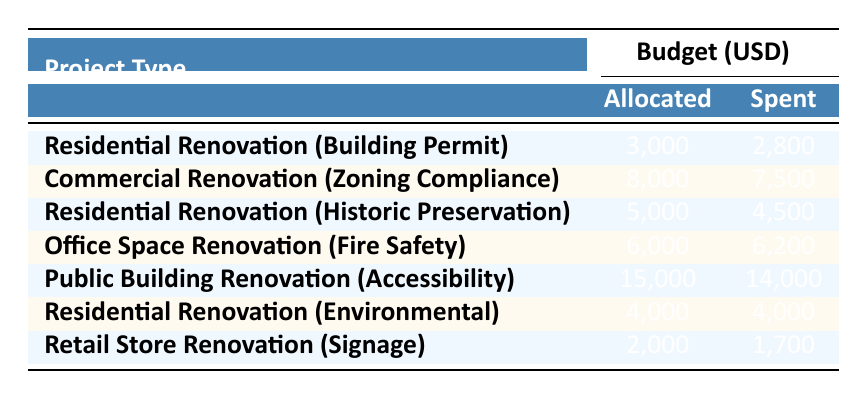What is the allocated budget for Residential Renovation under Building Permit? The table indicates that for the Residential Renovation project with the legal requirement of a Building Permit, the allocated budget is listed as 3,000.
Answer: 3,000 How much was spent on Commercial Renovation for Zoning Compliance? According to the table, the spent budget for the Commercial Renovation project under Zoning Compliance is specified as 7,500.
Answer: 7,500 What is the total allocated budget for all Residential Renovation projects? Summing the allocated budgets for all Residential Renovation projects: (3,000 + 5,000 + 4,000) gives us a total of 12,000.
Answer: 12,000 Did the spent budget exceed the allocated budget for Office Space Renovation? The table shows that the allocated budget for Office Space Renovation is 6,000 and the spent budget is 6,200. Since 6,200 is greater than 6,000, the statement is true.
Answer: Yes What is the average spent budget across all projects listed in the table? We calculate the average by first adding the spent budgets: (2,800 + 7,500 + 4,500 + 6,200 + 14,000 + 4,000 + 1,700) = 40,700. There are 7 projects, so dividing 40,700 by 7 gives an average spent budget approximately equal to 5,810.
Answer: 5,810 Which project type had the smallest difference between allocated and spent budgets? The differences between allocated and spent budgets for all projects are calculated as follows: Building Permit: 200, Zoning Compliance: 500, Historic Preservation: 500, Fire Safety: -200, Accessibility: 1,000, Environmental: 0, Signage: 300. The smallest difference is 0 for Residential Renovation (Environmental).
Answer: Environmental Renovation What is the total spent budget for Public Building Renovation and Retail Store Renovation? Reviewing the table, the spent budgets are 14,000 for Public Building Renovation and 1,700 for Retail Store Renovation. Adding these two amounts gives us 14,000 + 1,700 = 15,700.
Answer: 15,700 